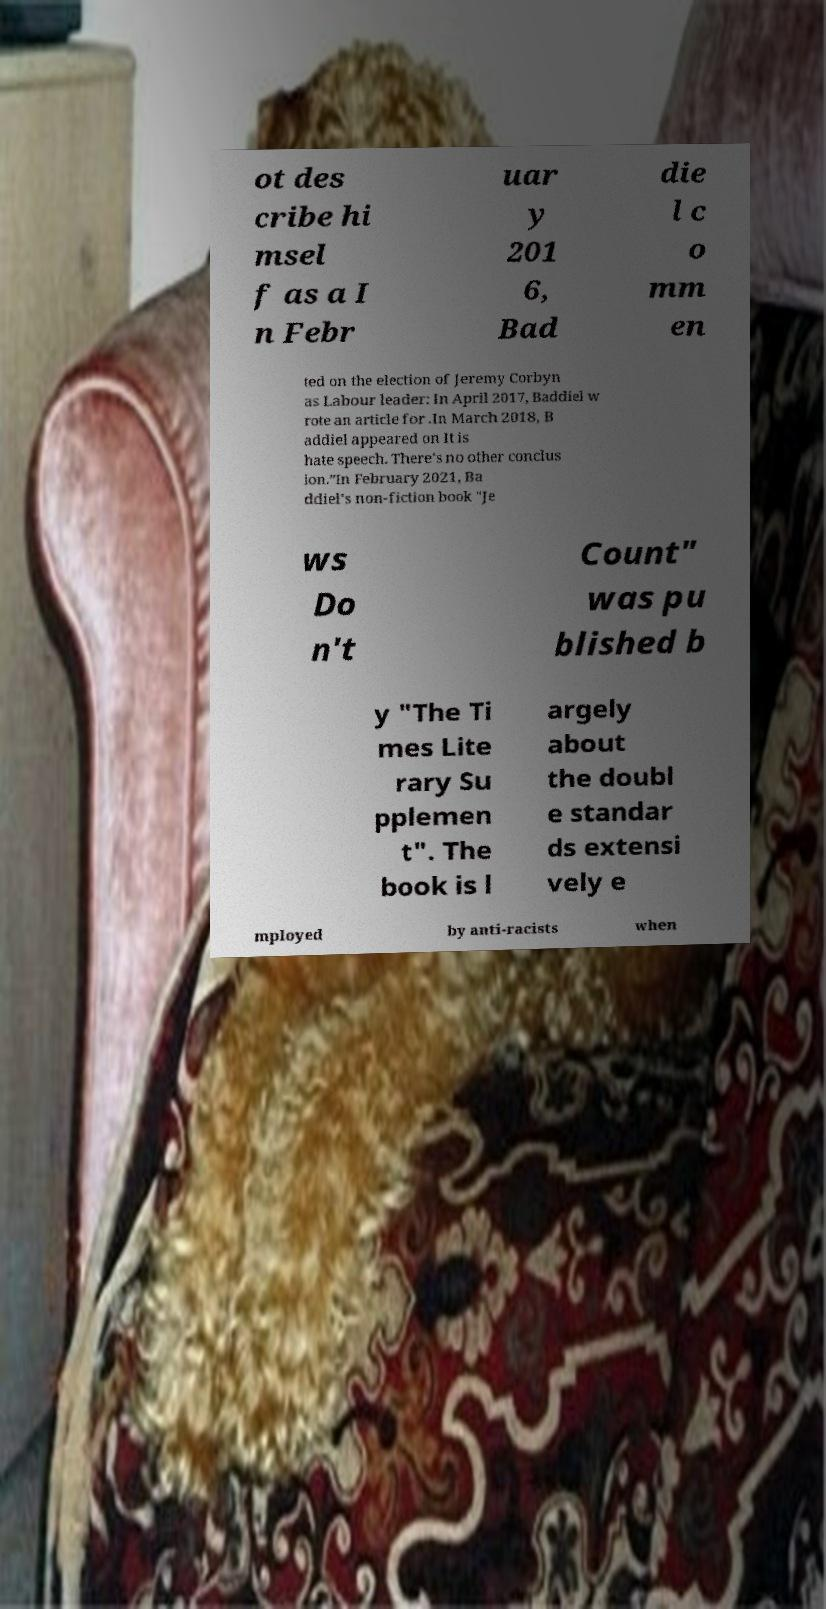For documentation purposes, I need the text within this image transcribed. Could you provide that? ot des cribe hi msel f as a I n Febr uar y 201 6, Bad die l c o mm en ted on the election of Jeremy Corbyn as Labour leader: In April 2017, Baddiel w rote an article for .In March 2018, B addiel appeared on It is hate speech. There's no other conclus ion.”In February 2021, Ba ddiel's non-fiction book "Je ws Do n't Count" was pu blished b y "The Ti mes Lite rary Su pplemen t". The book is l argely about the doubl e standar ds extensi vely e mployed by anti-racists when 